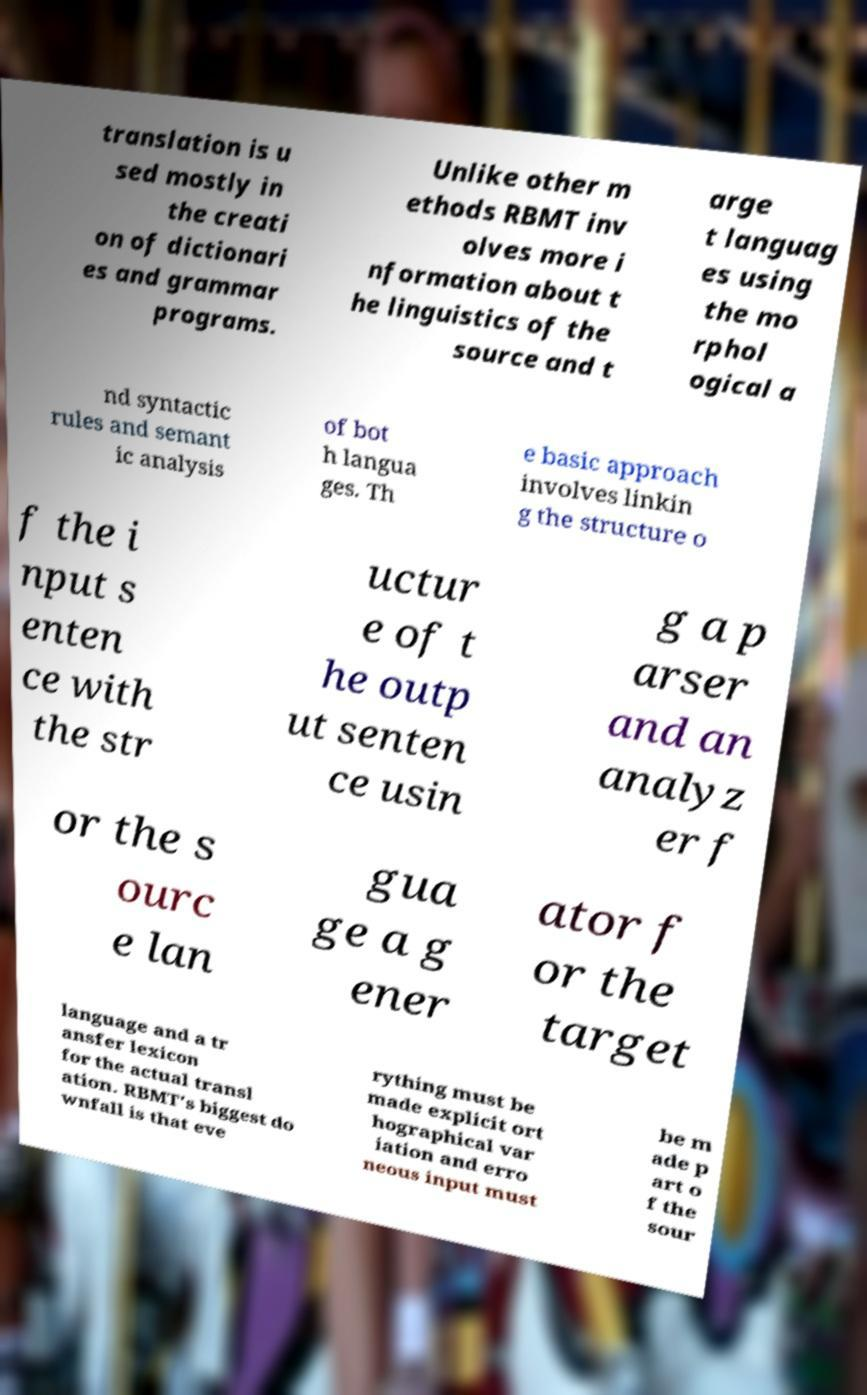Can you read and provide the text displayed in the image?This photo seems to have some interesting text. Can you extract and type it out for me? translation is u sed mostly in the creati on of dictionari es and grammar programs. Unlike other m ethods RBMT inv olves more i nformation about t he linguistics of the source and t arge t languag es using the mo rphol ogical a nd syntactic rules and semant ic analysis of bot h langua ges. Th e basic approach involves linkin g the structure o f the i nput s enten ce with the str uctur e of t he outp ut senten ce usin g a p arser and an analyz er f or the s ourc e lan gua ge a g ener ator f or the target language and a tr ansfer lexicon for the actual transl ation. RBMT's biggest do wnfall is that eve rything must be made explicit ort hographical var iation and erro neous input must be m ade p art o f the sour 